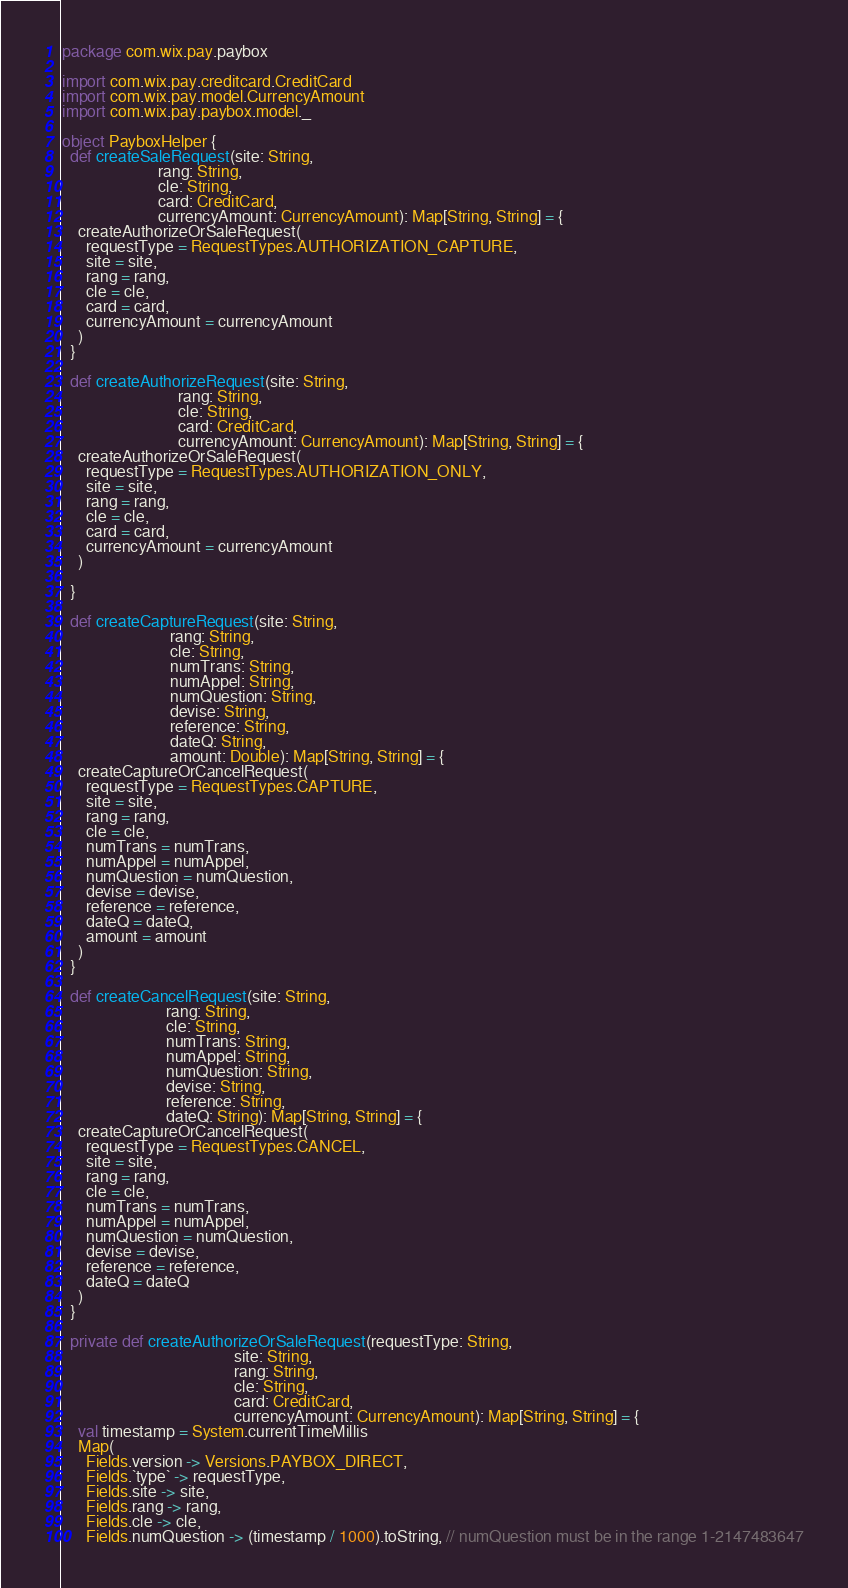<code> <loc_0><loc_0><loc_500><loc_500><_Scala_>package com.wix.pay.paybox

import com.wix.pay.creditcard.CreditCard
import com.wix.pay.model.CurrencyAmount
import com.wix.pay.paybox.model._

object PayboxHelper {
  def createSaleRequest(site: String,
                        rang: String,
                        cle: String,
                        card: CreditCard,
                        currencyAmount: CurrencyAmount): Map[String, String] = {
    createAuthorizeOrSaleRequest(
      requestType = RequestTypes.AUTHORIZATION_CAPTURE,
      site = site,
      rang = rang,
      cle = cle,
      card = card,
      currencyAmount = currencyAmount
    )
  }

  def createAuthorizeRequest(site: String,
                             rang: String,
                             cle: String,
                             card: CreditCard,
                             currencyAmount: CurrencyAmount): Map[String, String] = {
    createAuthorizeOrSaleRequest(
      requestType = RequestTypes.AUTHORIZATION_ONLY,
      site = site,
      rang = rang,
      cle = cle,
      card = card,
      currencyAmount = currencyAmount
    )

  }

  def createCaptureRequest(site: String,
                           rang: String,
                           cle: String,
                           numTrans: String,
                           numAppel: String,
                           numQuestion: String,
                           devise: String,
                           reference: String,
                           dateQ: String,
                           amount: Double): Map[String, String] = {
    createCaptureOrCancelRequest(
      requestType = RequestTypes.CAPTURE,
      site = site,
      rang = rang,
      cle = cle,
      numTrans = numTrans,
      numAppel = numAppel,
      numQuestion = numQuestion,
      devise = devise,
      reference = reference,
      dateQ = dateQ,
      amount = amount
    )
  }

  def createCancelRequest(site: String,
                          rang: String,
                          cle: String,
                          numTrans: String,
                          numAppel: String,
                          numQuestion: String,
                          devise: String,
                          reference: String,
                          dateQ: String): Map[String, String] = {
    createCaptureOrCancelRequest(
      requestType = RequestTypes.CANCEL,
      site = site,
      rang = rang,
      cle = cle,
      numTrans = numTrans,
      numAppel = numAppel,
      numQuestion = numQuestion,
      devise = devise,
      reference = reference,
      dateQ = dateQ
    )
  }

  private def createAuthorizeOrSaleRequest(requestType: String,
                                           site: String,
                                           rang: String,
                                           cle: String,
                                           card: CreditCard,
                                           currencyAmount: CurrencyAmount): Map[String, String] = {
    val timestamp = System.currentTimeMillis
    Map(
      Fields.version -> Versions.PAYBOX_DIRECT,
      Fields.`type` -> requestType,
      Fields.site -> site,
      Fields.rang -> rang,
      Fields.cle -> cle,
      Fields.numQuestion -> (timestamp / 1000).toString, // numQuestion must be in the range 1-2147483647</code> 